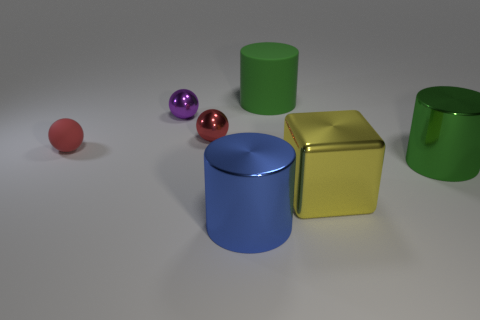How many small green metallic cubes are there?
Give a very brief answer. 0. What number of cylinders are either small purple metallic objects or large rubber things?
Your answer should be very brief. 1. There is a big metal cylinder on the left side of the big green metal cylinder; what number of big objects are behind it?
Keep it short and to the point. 3. Are the small purple thing and the block made of the same material?
Your response must be concise. Yes. There is another sphere that is the same color as the small rubber sphere; what is its size?
Ensure brevity in your answer.  Small. Are there any tiny red cubes made of the same material as the large yellow thing?
Keep it short and to the point. No. What color is the metallic cube that is in front of the large thing behind the big shiny thing on the right side of the cube?
Make the answer very short. Yellow. How many yellow objects are either tiny metal objects or large blocks?
Provide a succinct answer. 1. How many blue objects are the same shape as the yellow metallic object?
Give a very brief answer. 0. There is a green matte object that is the same size as the blue shiny cylinder; what is its shape?
Offer a terse response. Cylinder. 